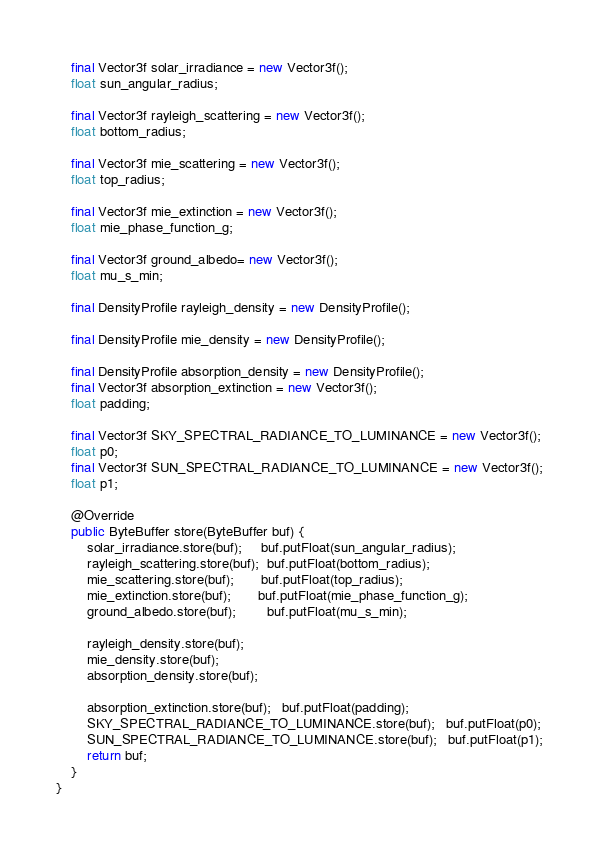Convert code to text. <code><loc_0><loc_0><loc_500><loc_500><_Java_>    final Vector3f solar_irradiance = new Vector3f();
    float sun_angular_radius;

    final Vector3f rayleigh_scattering = new Vector3f();
    float bottom_radius;

    final Vector3f mie_scattering = new Vector3f();
    float top_radius;

    final Vector3f mie_extinction = new Vector3f();
    float mie_phase_function_g;

    final Vector3f ground_albedo= new Vector3f();
    float mu_s_min;

    final DensityProfile rayleigh_density = new DensityProfile();

    final DensityProfile mie_density = new DensityProfile();

    final DensityProfile absorption_density = new DensityProfile();
    final Vector3f absorption_extinction = new Vector3f();
    float padding;

    final Vector3f SKY_SPECTRAL_RADIANCE_TO_LUMINANCE = new Vector3f();
    float p0;
    final Vector3f SUN_SPECTRAL_RADIANCE_TO_LUMINANCE = new Vector3f();
    float p1;

    @Override
    public ByteBuffer store(ByteBuffer buf) {
        solar_irradiance.store(buf);     buf.putFloat(sun_angular_radius);
        rayleigh_scattering.store(buf);  buf.putFloat(bottom_radius);
        mie_scattering.store(buf);       buf.putFloat(top_radius);
        mie_extinction.store(buf);       buf.putFloat(mie_phase_function_g);
        ground_albedo.store(buf);        buf.putFloat(mu_s_min);

        rayleigh_density.store(buf);
        mie_density.store(buf);
        absorption_density.store(buf);

        absorption_extinction.store(buf);   buf.putFloat(padding);
        SKY_SPECTRAL_RADIANCE_TO_LUMINANCE.store(buf);   buf.putFloat(p0);
        SUN_SPECTRAL_RADIANCE_TO_LUMINANCE.store(buf);   buf.putFloat(p1);
        return buf;
    }
}
</code> 